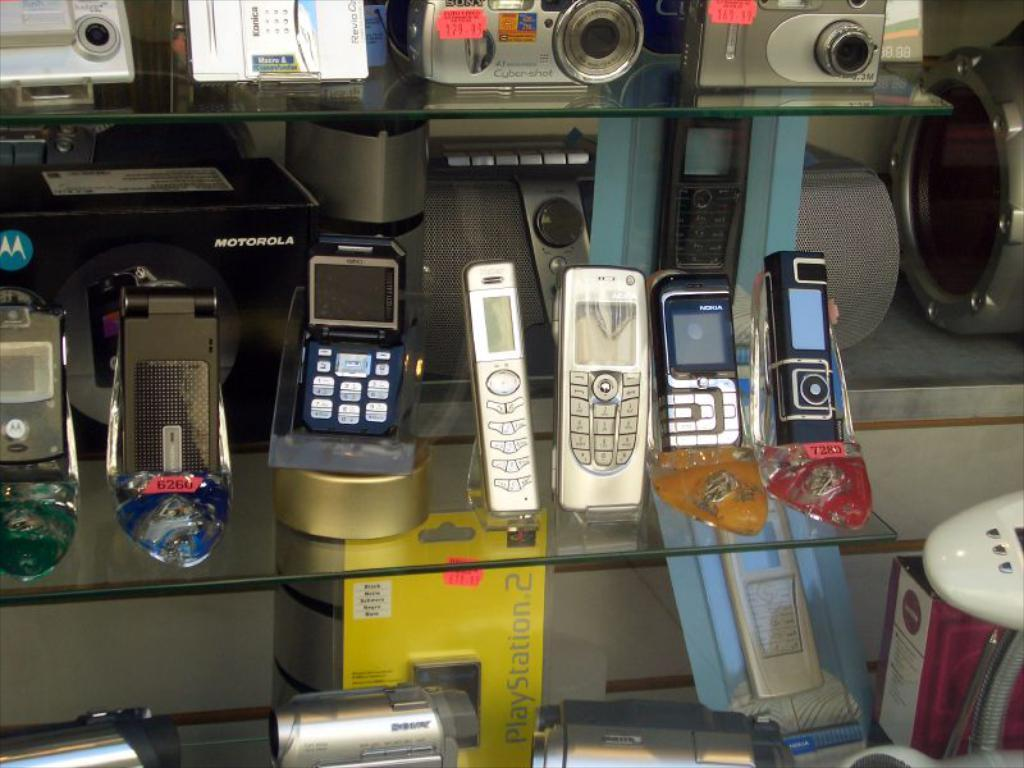<image>
Present a compact description of the photo's key features. A glass shelf has lots of old cell phones on it and a package that says PlayStation 2. 